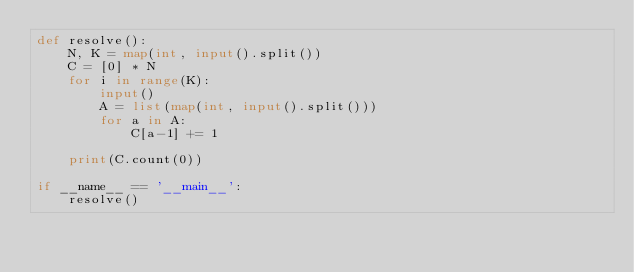Convert code to text. <code><loc_0><loc_0><loc_500><loc_500><_Python_>def resolve():
    N, K = map(int, input().split())
    C = [0] * N
    for i in range(K):
        input()
        A = list(map(int, input().split()))
        for a in A:
            C[a-1] += 1

    print(C.count(0))

if __name__ == '__main__':
    resolve()
</code> 